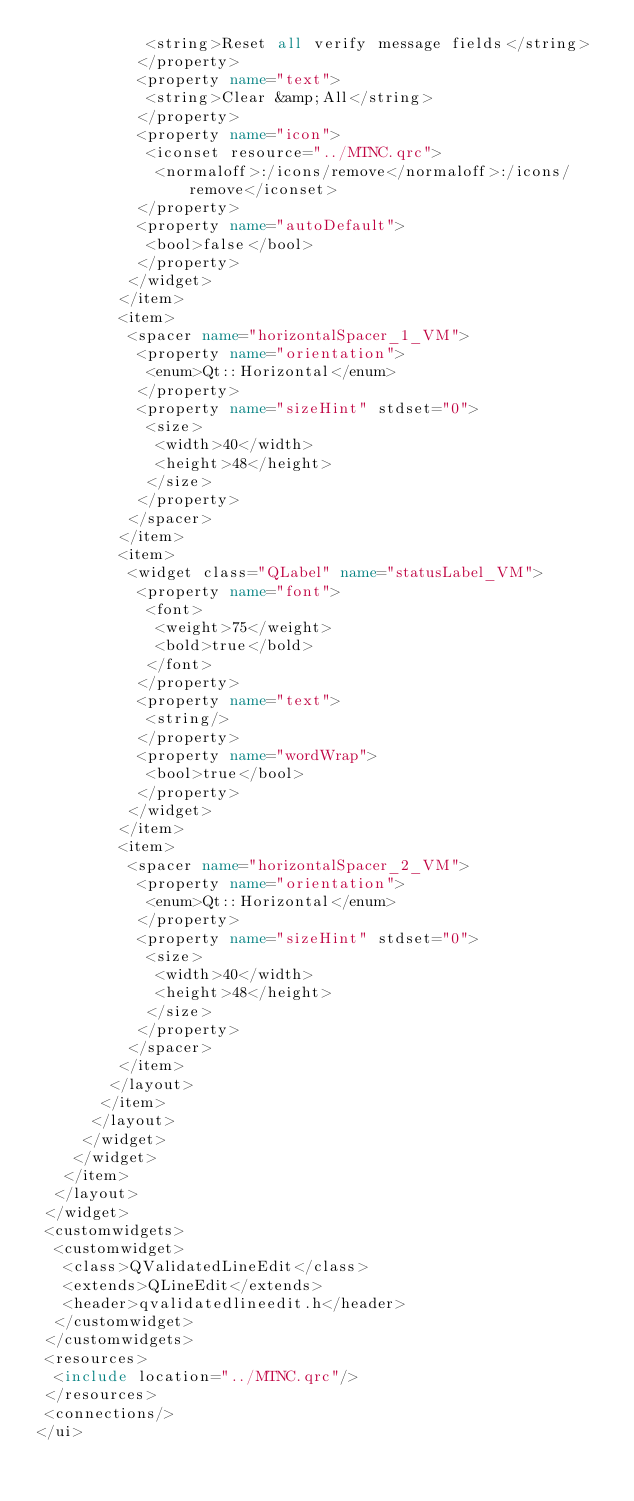Convert code to text. <code><loc_0><loc_0><loc_500><loc_500><_XML_>            <string>Reset all verify message fields</string>
           </property>
           <property name="text">
            <string>Clear &amp;All</string>
           </property>
           <property name="icon">
            <iconset resource="../MTNC.qrc">
             <normaloff>:/icons/remove</normaloff>:/icons/remove</iconset>
           </property>
           <property name="autoDefault">
            <bool>false</bool>
           </property>
          </widget>
         </item>
         <item>
          <spacer name="horizontalSpacer_1_VM">
           <property name="orientation">
            <enum>Qt::Horizontal</enum>
           </property>
           <property name="sizeHint" stdset="0">
            <size>
             <width>40</width>
             <height>48</height>
            </size>
           </property>
          </spacer>
         </item>
         <item>
          <widget class="QLabel" name="statusLabel_VM">
           <property name="font">
            <font>
             <weight>75</weight>
             <bold>true</bold>
            </font>
           </property>
           <property name="text">
            <string/>
           </property>
           <property name="wordWrap">
            <bool>true</bool>
           </property>
          </widget>
         </item>
         <item>
          <spacer name="horizontalSpacer_2_VM">
           <property name="orientation">
            <enum>Qt::Horizontal</enum>
           </property>
           <property name="sizeHint" stdset="0">
            <size>
             <width>40</width>
             <height>48</height>
            </size>
           </property>
          </spacer>
         </item>
        </layout>
       </item>
      </layout>
     </widget>
    </widget>
   </item>
  </layout>
 </widget>
 <customwidgets>
  <customwidget>
   <class>QValidatedLineEdit</class>
   <extends>QLineEdit</extends>
   <header>qvalidatedlineedit.h</header>
  </customwidget>
 </customwidgets>
 <resources>
  <include location="../MTNC.qrc"/>
 </resources>
 <connections/>
</ui>
</code> 